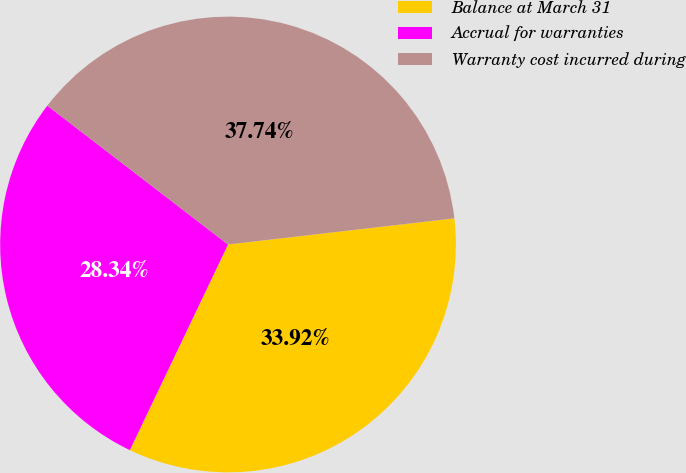Convert chart. <chart><loc_0><loc_0><loc_500><loc_500><pie_chart><fcel>Balance at March 31<fcel>Accrual for warranties<fcel>Warranty cost incurred during<nl><fcel>33.92%<fcel>28.34%<fcel>37.74%<nl></chart> 